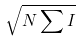Convert formula to latex. <formula><loc_0><loc_0><loc_500><loc_500>\sqrt { { N \sum { I } } }</formula> 